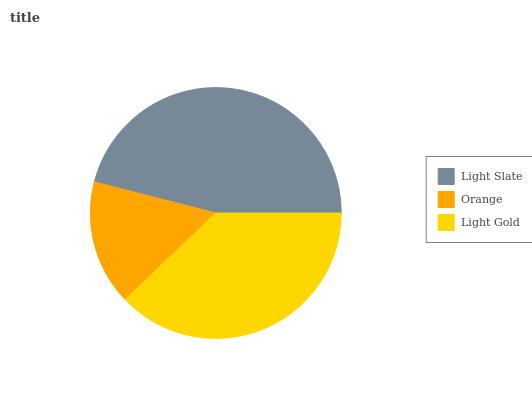Is Orange the minimum?
Answer yes or no. Yes. Is Light Slate the maximum?
Answer yes or no. Yes. Is Light Gold the minimum?
Answer yes or no. No. Is Light Gold the maximum?
Answer yes or no. No. Is Light Gold greater than Orange?
Answer yes or no. Yes. Is Orange less than Light Gold?
Answer yes or no. Yes. Is Orange greater than Light Gold?
Answer yes or no. No. Is Light Gold less than Orange?
Answer yes or no. No. Is Light Gold the high median?
Answer yes or no. Yes. Is Light Gold the low median?
Answer yes or no. Yes. Is Light Slate the high median?
Answer yes or no. No. Is Orange the low median?
Answer yes or no. No. 